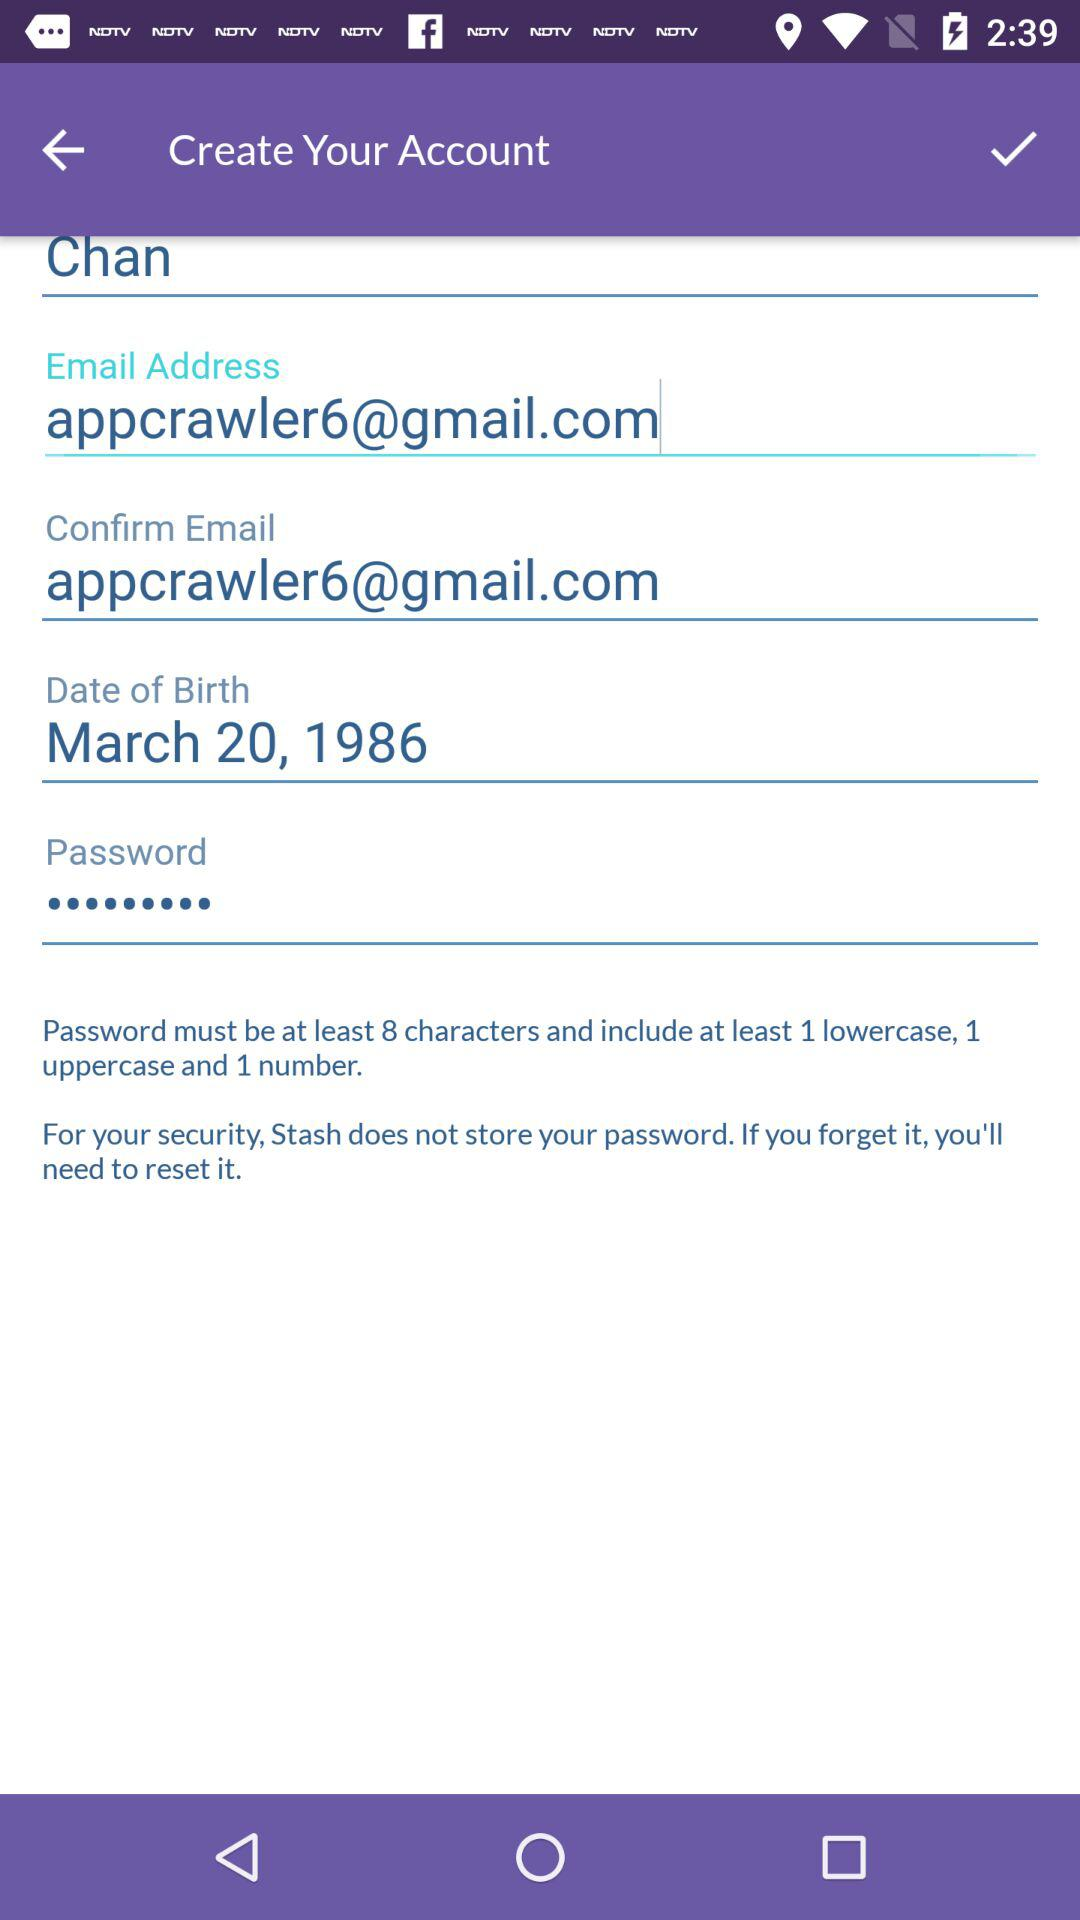What is the date of birth? The date of birth is March 20, 1986. 